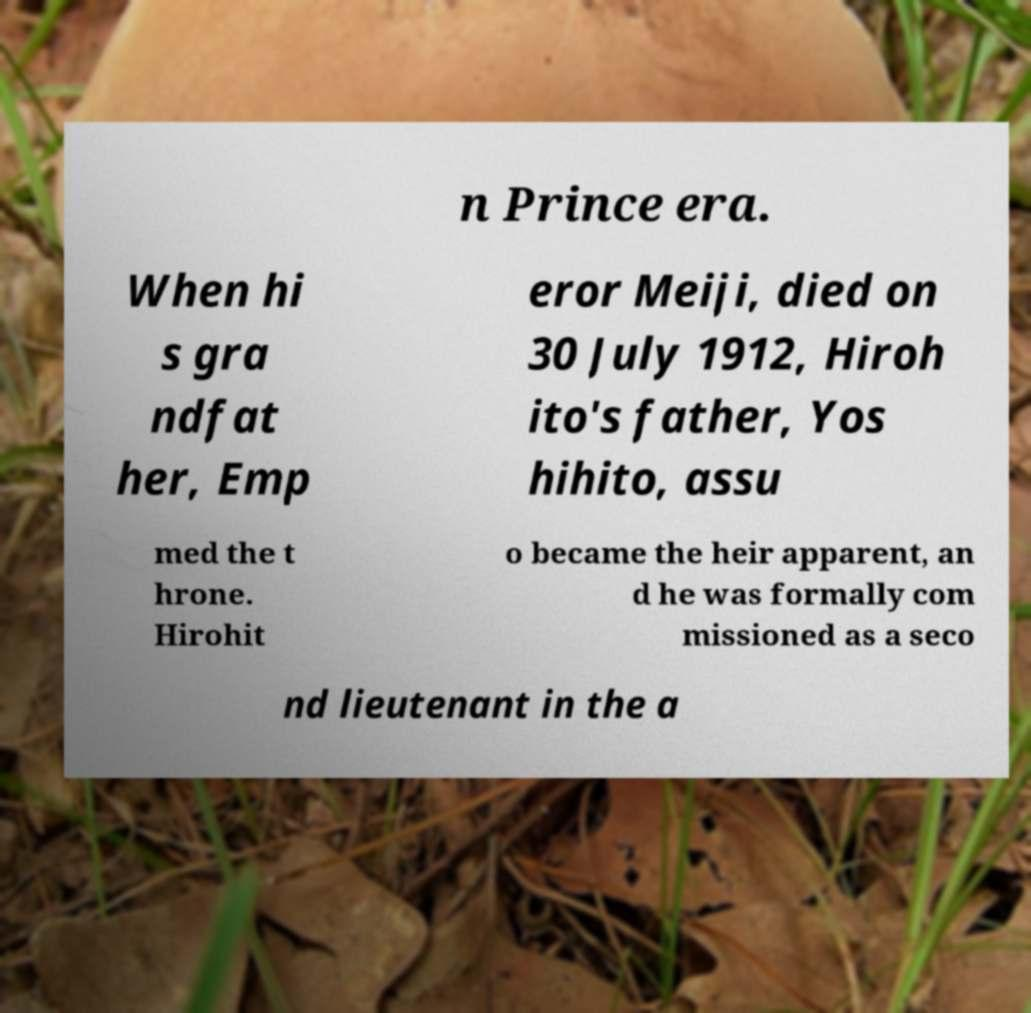What messages or text are displayed in this image? I need them in a readable, typed format. n Prince era. When hi s gra ndfat her, Emp eror Meiji, died on 30 July 1912, Hiroh ito's father, Yos hihito, assu med the t hrone. Hirohit o became the heir apparent, an d he was formally com missioned as a seco nd lieutenant in the a 